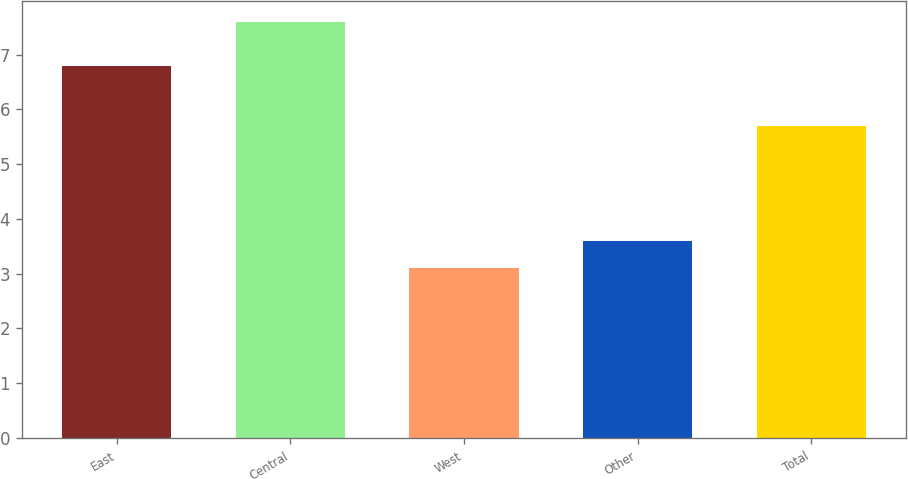Convert chart to OTSL. <chart><loc_0><loc_0><loc_500><loc_500><bar_chart><fcel>East<fcel>Central<fcel>West<fcel>Other<fcel>Total<nl><fcel>6.8<fcel>7.6<fcel>3.1<fcel>3.6<fcel>5.7<nl></chart> 